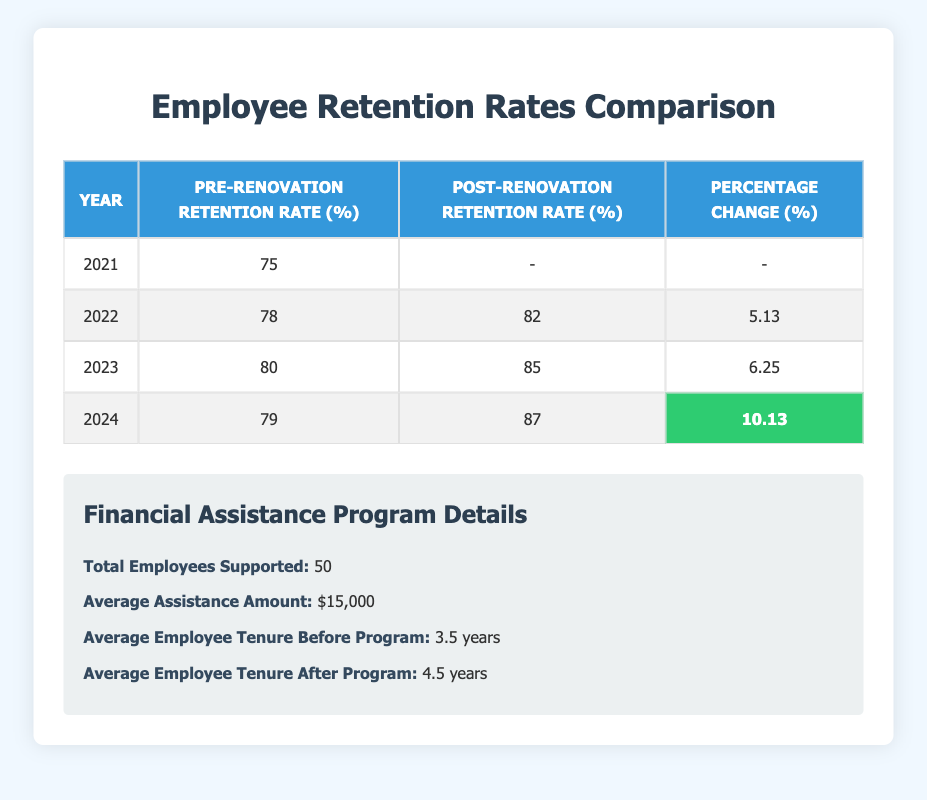What was the retention rate in 2021? The retention rate for the year 2021 is directly listed in the table under the "Pre-Renovation Retention Rate" column, which shows 75%.
Answer: 75% What is the percentage change in employee retention rate from 2022 to 2023? To find the percentage change from 2022 to 2023, we look at the post-renovation retention rates: 85% in 2023 and 82% in 2022. The percentage change is calculated as ((85 - 82) / 82) * 100 = 3.66%.
Answer: 3.66% Did employee retention rates improve each year from 2021 to 2024? We check the "Percentage Change" column from 2021 to 2024. The only year without post-renovation data is 2021. From 2022 to 2024, the retention rates improved consistently: 5.13%, 6.25%, and 10.13%. Thus, the trend indicates improvement, but we cannot assess 2021 due to no post-renovation data.
Answer: No What was the average employee retention rate before the renovation financial assistance program from 2022 to 2024? We calculate this by averaging the "Pre-Renovation Retention Rate" values for 2022, 2023, and 2024: (78 + 80 + 79) / 3 = 79%.
Answer: 79% How many employees received financial assistance from the program? The table states that a total of 50 employees were supported by the renovation financial assistance program.
Answer: 50 What is the average increase in retention rate following the renovation assistance program from 2022 to 2024? We find the retention rates that improved from 2022 to 2024: 82% (2022), 85% (2023), and 87% (2024). We calculate the total increase: (85 - 82) + (87 - 85) = 3 + 2 = 5%. Dividing by the number of changes (2 years) gives us an average increase of 2.5%.
Answer: 2.5% Did the average employee tenure increase after the program? The average employee tenure before the program was 3.5 years, and after the program, it was 4.5 years. Since 4.5 years is greater than 3.5 years, the tenure indeed increased after the program.
Answer: Yes What was the retention rate for the pre-renovation period in 2023? In 2023, the pre-renovation retention rate is provided in the table, which shows a value of 80%.
Answer: 80% Which year had the highest percentage change in retention rate and what was the value? We check the "Percentage Change" column for all years with post-renovation rates. The highest percentage change is 10.13%, which occurred in the year 2024.
Answer: 2024, 10.13% 